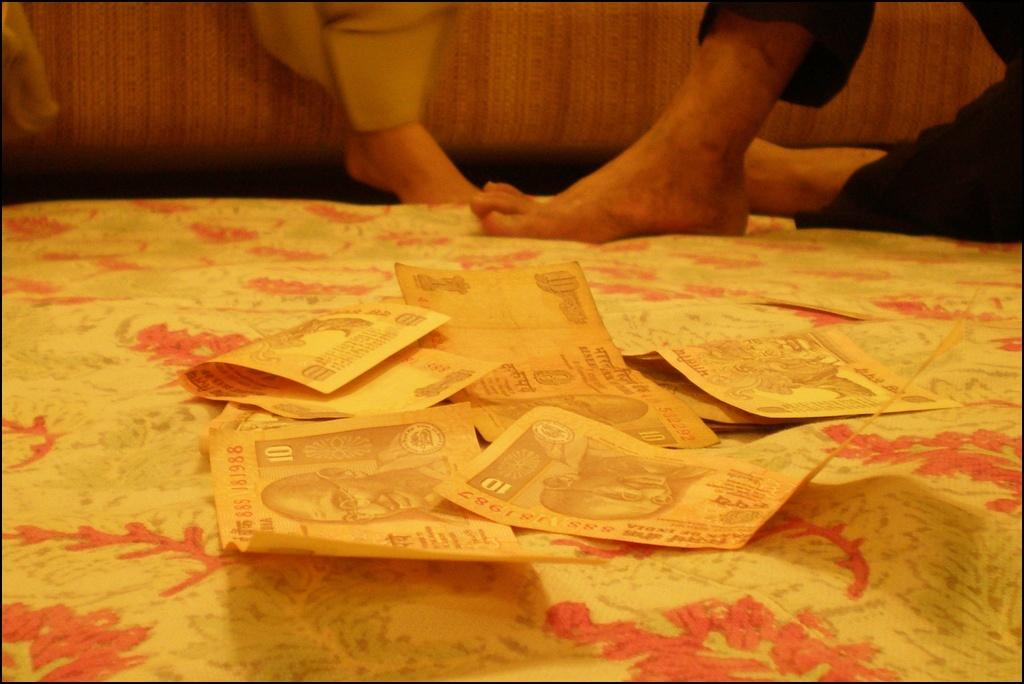How many people are present in the image? There are two persons sitting in the image. What can be seen in the image besides the people? There are ten rupee notes in the image. What is the pattern or design at the bottom of the image? There is a floral cloth at the bottom of the image. What color is the crayon being used by the person in the image? There is no crayon present in the image. How many gloves can be seen on the person's hands in the image? There are no gloves visible in the image. 